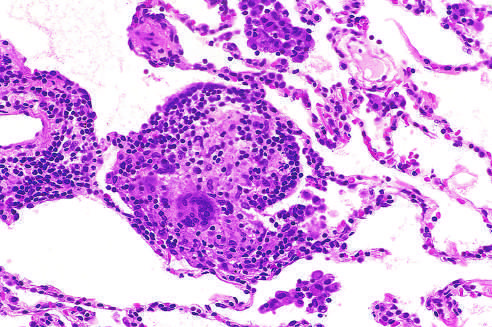re histologic features characteristic?
Answer the question using a single word or phrase. No 